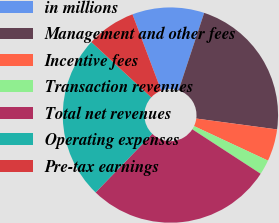Convert chart. <chart><loc_0><loc_0><loc_500><loc_500><pie_chart><fcel>in millions<fcel>Management and other fees<fcel>Incentive fees<fcel>Transaction revenues<fcel>Total net revenues<fcel>Operating expenses<fcel>Pre-tax earnings<nl><fcel>10.81%<fcel>22.05%<fcel>4.82%<fcel>2.23%<fcel>28.05%<fcel>24.63%<fcel>7.4%<nl></chart> 